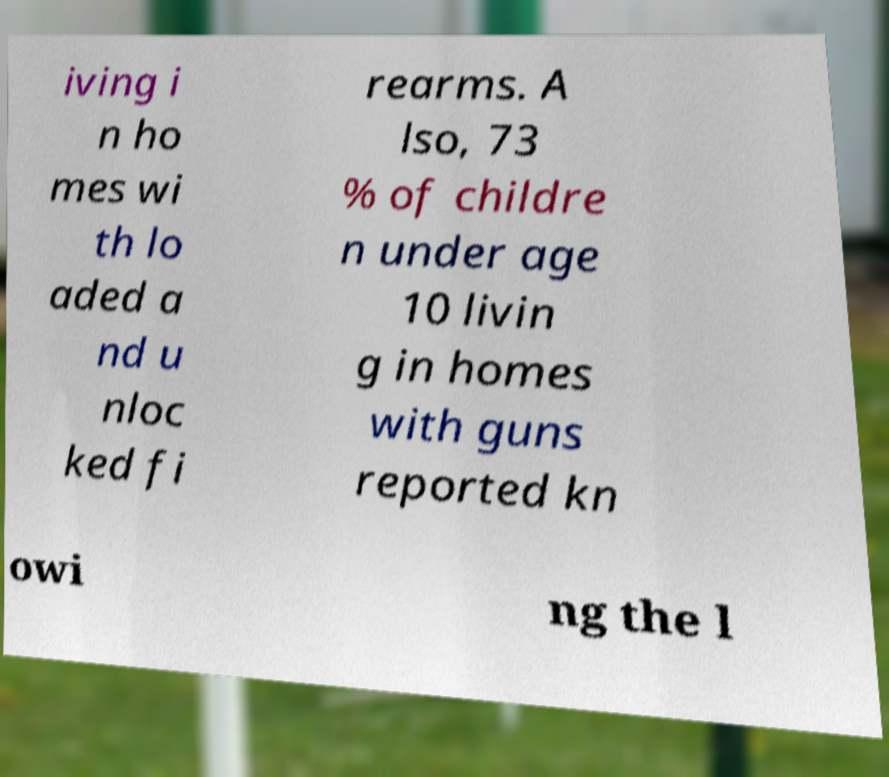There's text embedded in this image that I need extracted. Can you transcribe it verbatim? iving i n ho mes wi th lo aded a nd u nloc ked fi rearms. A lso, 73 % of childre n under age 10 livin g in homes with guns reported kn owi ng the l 